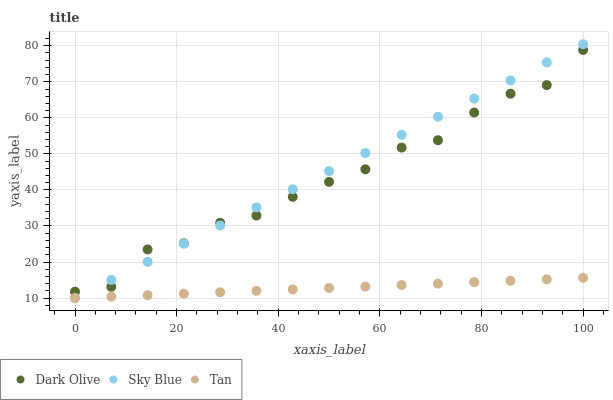Does Tan have the minimum area under the curve?
Answer yes or no. Yes. Does Sky Blue have the maximum area under the curve?
Answer yes or no. Yes. Does Dark Olive have the minimum area under the curve?
Answer yes or no. No. Does Dark Olive have the maximum area under the curve?
Answer yes or no. No. Is Tan the smoothest?
Answer yes or no. Yes. Is Dark Olive the roughest?
Answer yes or no. Yes. Is Dark Olive the smoothest?
Answer yes or no. No. Is Tan the roughest?
Answer yes or no. No. Does Sky Blue have the lowest value?
Answer yes or no. Yes. Does Dark Olive have the lowest value?
Answer yes or no. No. Does Sky Blue have the highest value?
Answer yes or no. Yes. Does Dark Olive have the highest value?
Answer yes or no. No. Is Tan less than Dark Olive?
Answer yes or no. Yes. Is Dark Olive greater than Tan?
Answer yes or no. Yes. Does Tan intersect Sky Blue?
Answer yes or no. Yes. Is Tan less than Sky Blue?
Answer yes or no. No. Is Tan greater than Sky Blue?
Answer yes or no. No. Does Tan intersect Dark Olive?
Answer yes or no. No. 